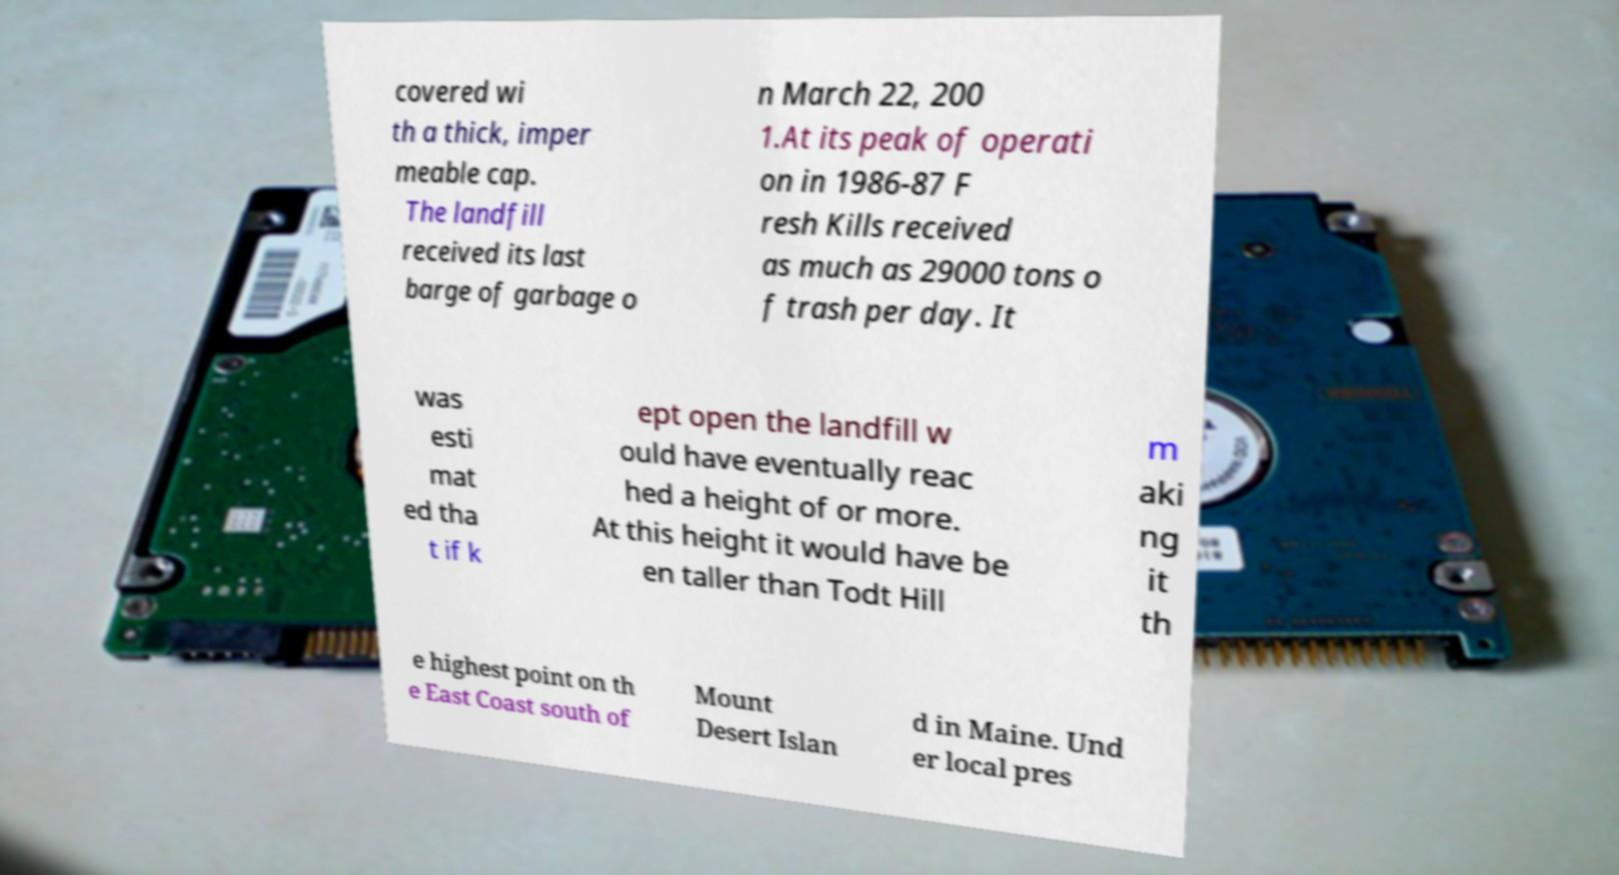Could you extract and type out the text from this image? covered wi th a thick, imper meable cap. The landfill received its last barge of garbage o n March 22, 200 1.At its peak of operati on in 1986-87 F resh Kills received as much as 29000 tons o f trash per day. It was esti mat ed tha t if k ept open the landfill w ould have eventually reac hed a height of or more. At this height it would have be en taller than Todt Hill m aki ng it th e highest point on th e East Coast south of Mount Desert Islan d in Maine. Und er local pres 